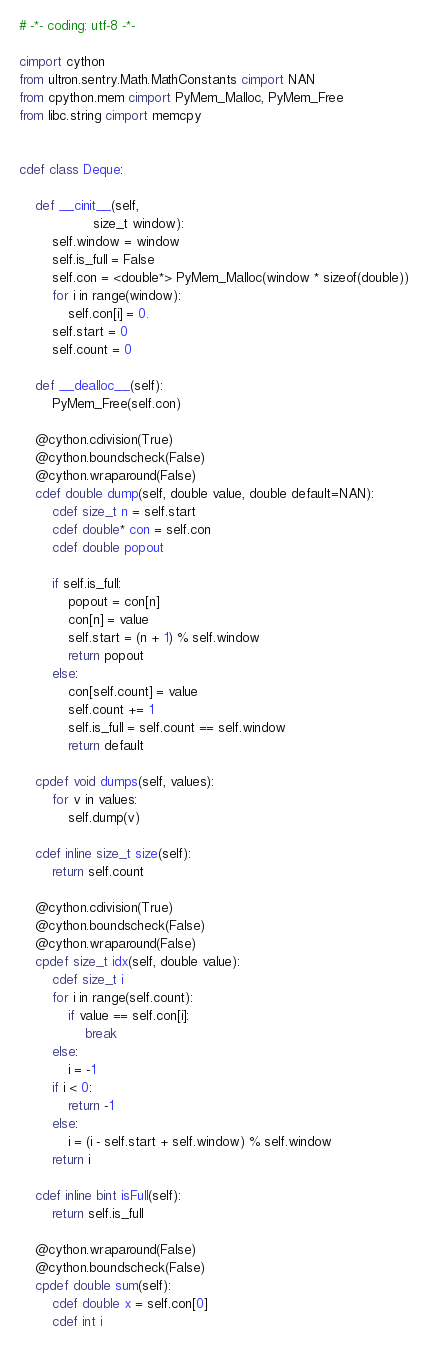<code> <loc_0><loc_0><loc_500><loc_500><_Cython_># -*- coding: utf-8 -*-

cimport cython
from ultron.sentry.Math.MathConstants cimport NAN
from cpython.mem cimport PyMem_Malloc, PyMem_Free
from libc.string cimport memcpy


cdef class Deque:

    def __cinit__(self,
                  size_t window):
        self.window = window
        self.is_full = False
        self.con = <double*> PyMem_Malloc(window * sizeof(double))
        for i in range(window):
            self.con[i] = 0.
        self.start = 0
        self.count = 0

    def __dealloc__(self):
        PyMem_Free(self.con)

    @cython.cdivision(True)
    @cython.boundscheck(False)
    @cython.wraparound(False)
    cdef double dump(self, double value, double default=NAN):
        cdef size_t n = self.start
        cdef double* con = self.con
        cdef double popout

        if self.is_full:
            popout = con[n]
            con[n] = value
            self.start = (n + 1) % self.window
            return popout
        else:
            con[self.count] = value
            self.count += 1
            self.is_full = self.count == self.window
            return default

    cpdef void dumps(self, values):
        for v in values:
            self.dump(v)

    cdef inline size_t size(self):
        return self.count

    @cython.cdivision(True)
    @cython.boundscheck(False)
    @cython.wraparound(False)
    cpdef size_t idx(self, double value):
        cdef size_t i
        for i in range(self.count):
            if value == self.con[i]:
                break
        else:
            i = -1
        if i < 0:
            return -1
        else:
            i = (i - self.start + self.window) % self.window
        return i

    cdef inline bint isFull(self):
        return self.is_full

    @cython.wraparound(False)
    @cython.boundscheck(False)
    cpdef double sum(self):
        cdef double x = self.con[0]
        cdef int i</code> 